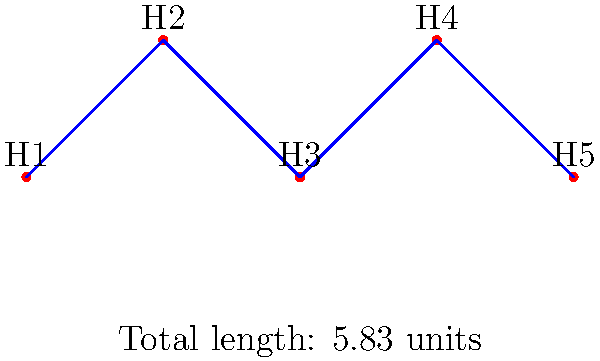The Cantu family and their neighbors want to connect their houses to a new utility line in the most efficient way possible. The diagram shows 5 houses (H1 to H5) and the optimal connections between them. If the cost of laying utility line is $1000 per unit length, what is the total cost of connecting all houses? To solve this problem, we need to follow these steps:

1. Recognize that the optimal connection forms a minimum spanning tree.
2. Calculate the total length of the connections:
   a. H1 to H2: $\sqrt{1^2 + 1^2} = \sqrt{2} \approx 1.41$ units
   b. H2 to H3: $\sqrt{1^2 + 1^2} = \sqrt{2} \approx 1.41$ units
   c. H3 to H4: $\sqrt{1^2 + 1^2} = \sqrt{2} \approx 1.41$ units
   d. H4 to H5: $\sqrt{1^2 + 1^2} = \sqrt{2} \approx 1.41$ units
3. Sum up the total length: $4 * \sqrt{2} \approx 5.83$ units
4. Multiply the total length by the cost per unit:
   $5.83 * $1000 = $5830$

Therefore, the total cost of connecting all houses is $5830.
Answer: $5830 